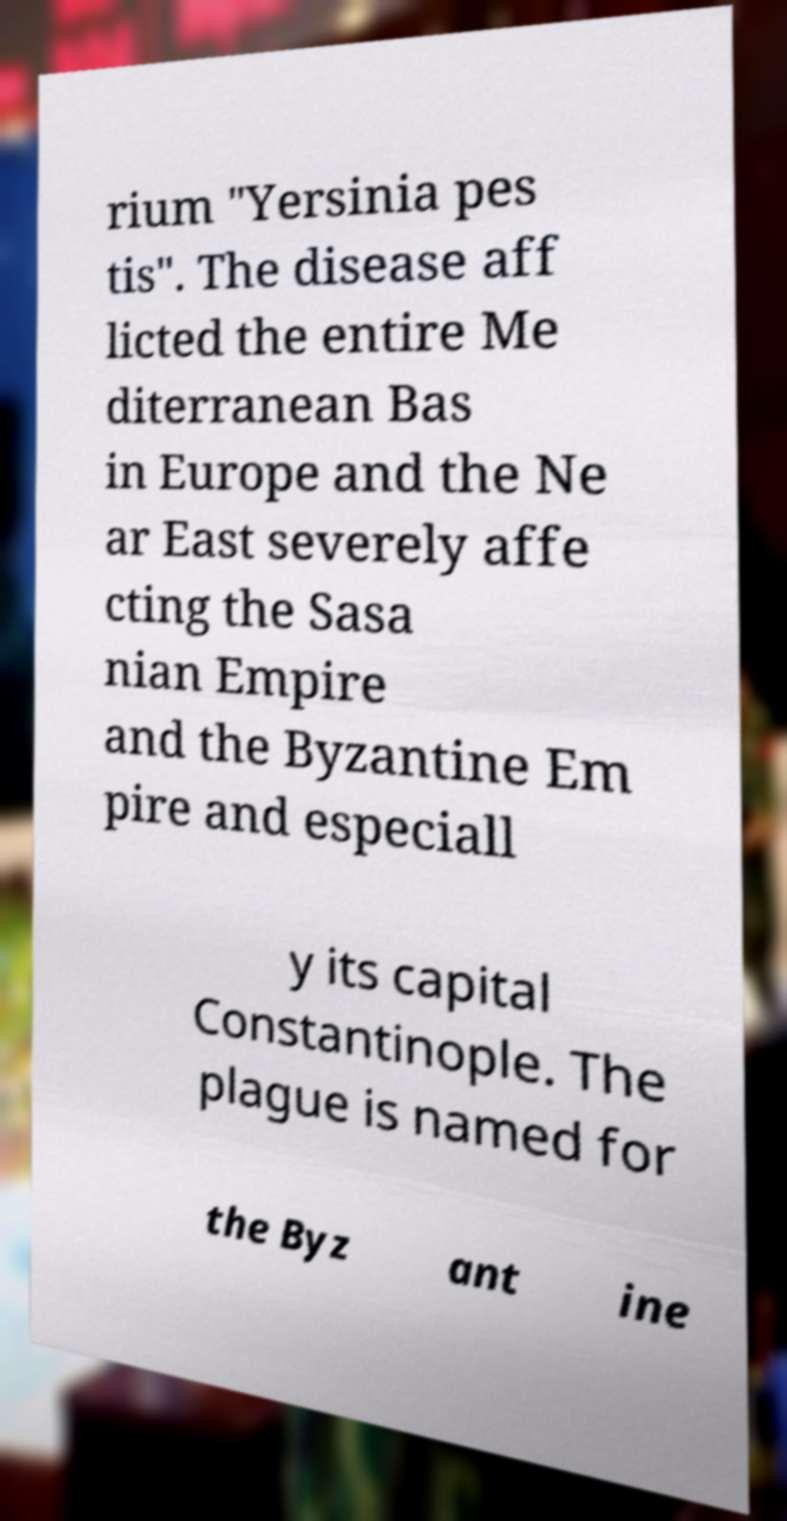I need the written content from this picture converted into text. Can you do that? rium "Yersinia pes tis". The disease aff licted the entire Me diterranean Bas in Europe and the Ne ar East severely affe cting the Sasa nian Empire and the Byzantine Em pire and especiall y its capital Constantinople. The plague is named for the Byz ant ine 